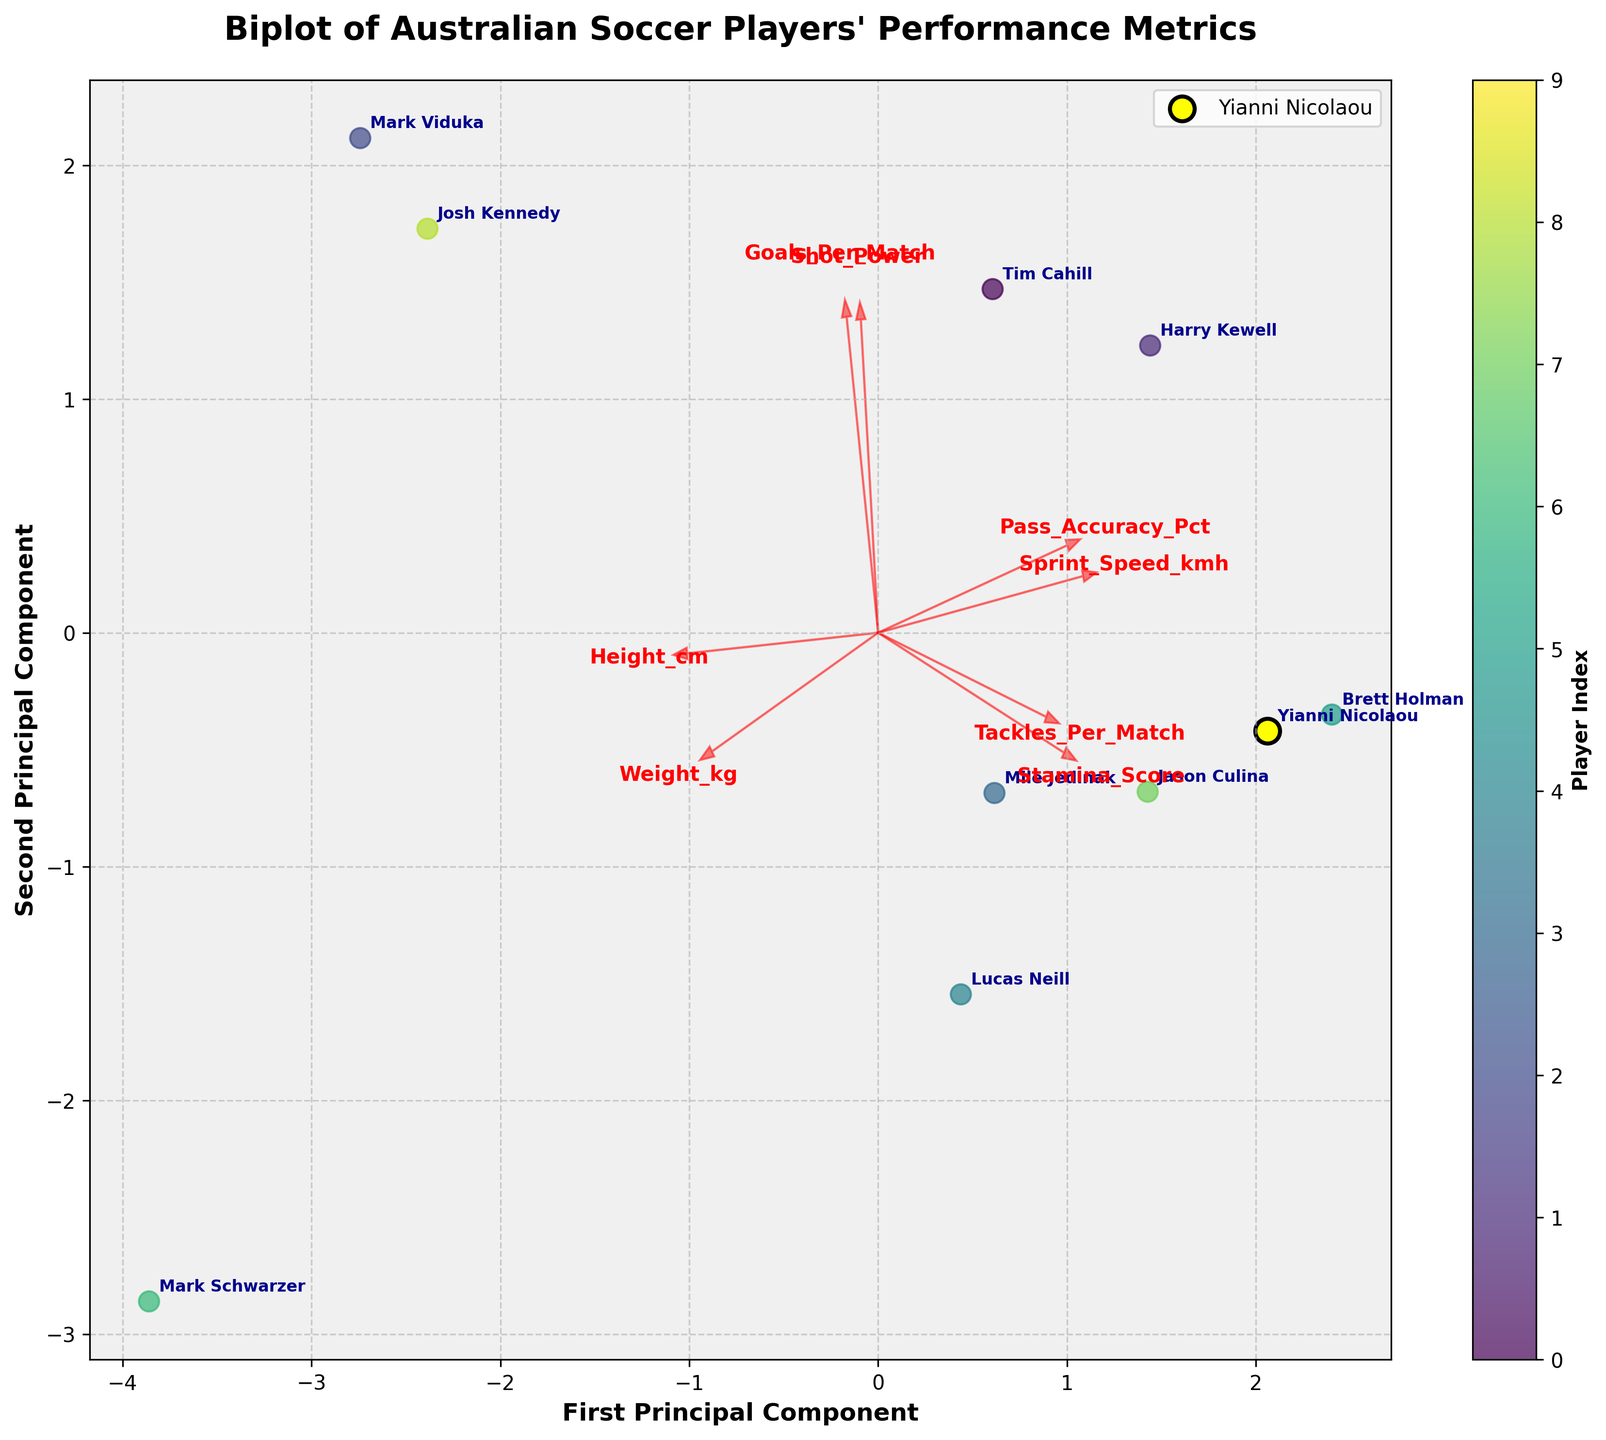What's the title of the figure? The title of the figure is located at the top and is generally bold and larger in font size compared to other text elements.
Answer: Biplot of Australian Soccer Players' Performance Metrics How many principal components are shown in the biplot? The axis labels indicate that two principal components are displayed, with one labeled "First Principal Component" and the other "Second Principal Component."
Answer: Two Which player has the highest value on the first principal component? By looking at the scatter plot, the player that is the farthest to the right on the x-axis represents the highest value on the first principal component.
Answer: Brett Holman Which feature vector is the most aligned with the first principal component? The alignment is determined by observing which arrow is pointing closest to directly horizontal (along the x-axis).
Answer: Stamina_Score What's the difference in first principal component scores between Tim Cahill and Jason Culina? Locate both Tim Cahill and Jason Culina on the plot, note their positions on the x-axis, and subtract the x-coordinate of Tim Cahill from that of Jason Culina.
Answer: ~0.1 (exact difference might require more precise measurement from the actual figure) Who has the highest goals per match? Examine the feature vector for "Goals_Per_Match" and identify the player that is farthest in the direction indicated by this arrow.
Answer: Mark Viduka Who is characterized by high shot power and accuracy and is closest together on the plot? Look for the cluster of points near the direction indicated by the "Shot_Power" and "Pass_Accuracy_Pct" arrowheads. Identify the closest pair within that cluster.
Answer: Harry Kewell and Brett Holman Which feature has the smallest influence on the first principal component? The feature with the vector arrow closest to the y-axis (vertical axis) has the smallest influence on the first principal component.
Answer: Goals_Per_Match Is Yianni Nicolaou closest to any other specific player? If so, who? Locate Yianni Nicolaou (marked distinctly with a yellow dot). Observe the surrounding players and determine the one closest to him in terms of distance on the plot.
Answer: Brett Holman What does the first principal component primarily represent in terms of player attributes? The first principal component can be interpreted by observing which feature vectors (attributes) have the longest arrows in the horizontal direction.
Answer: Stamina_Score and Sprint_Speed_kmh 